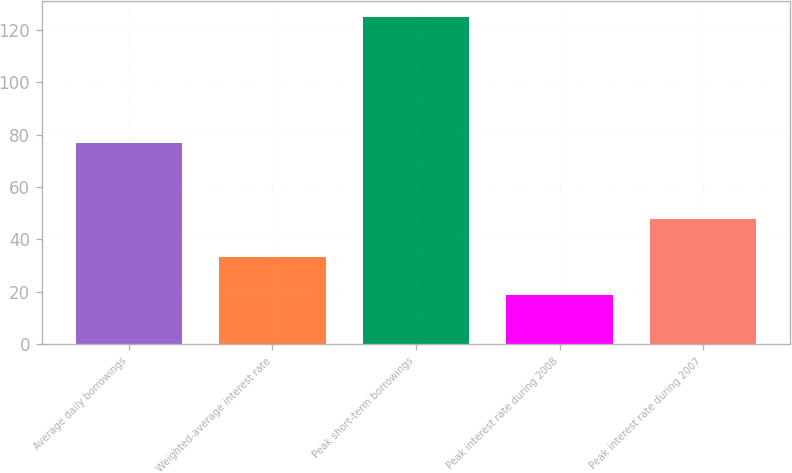Convert chart to OTSL. <chart><loc_0><loc_0><loc_500><loc_500><bar_chart><fcel>Average daily borrowings<fcel>Weighted-average interest rate<fcel>Peak short-term borrowings<fcel>Peak interest rate during 2008<fcel>Peak interest rate during 2007<nl><fcel>77.03<fcel>33.26<fcel>125<fcel>18.67<fcel>47.85<nl></chart> 